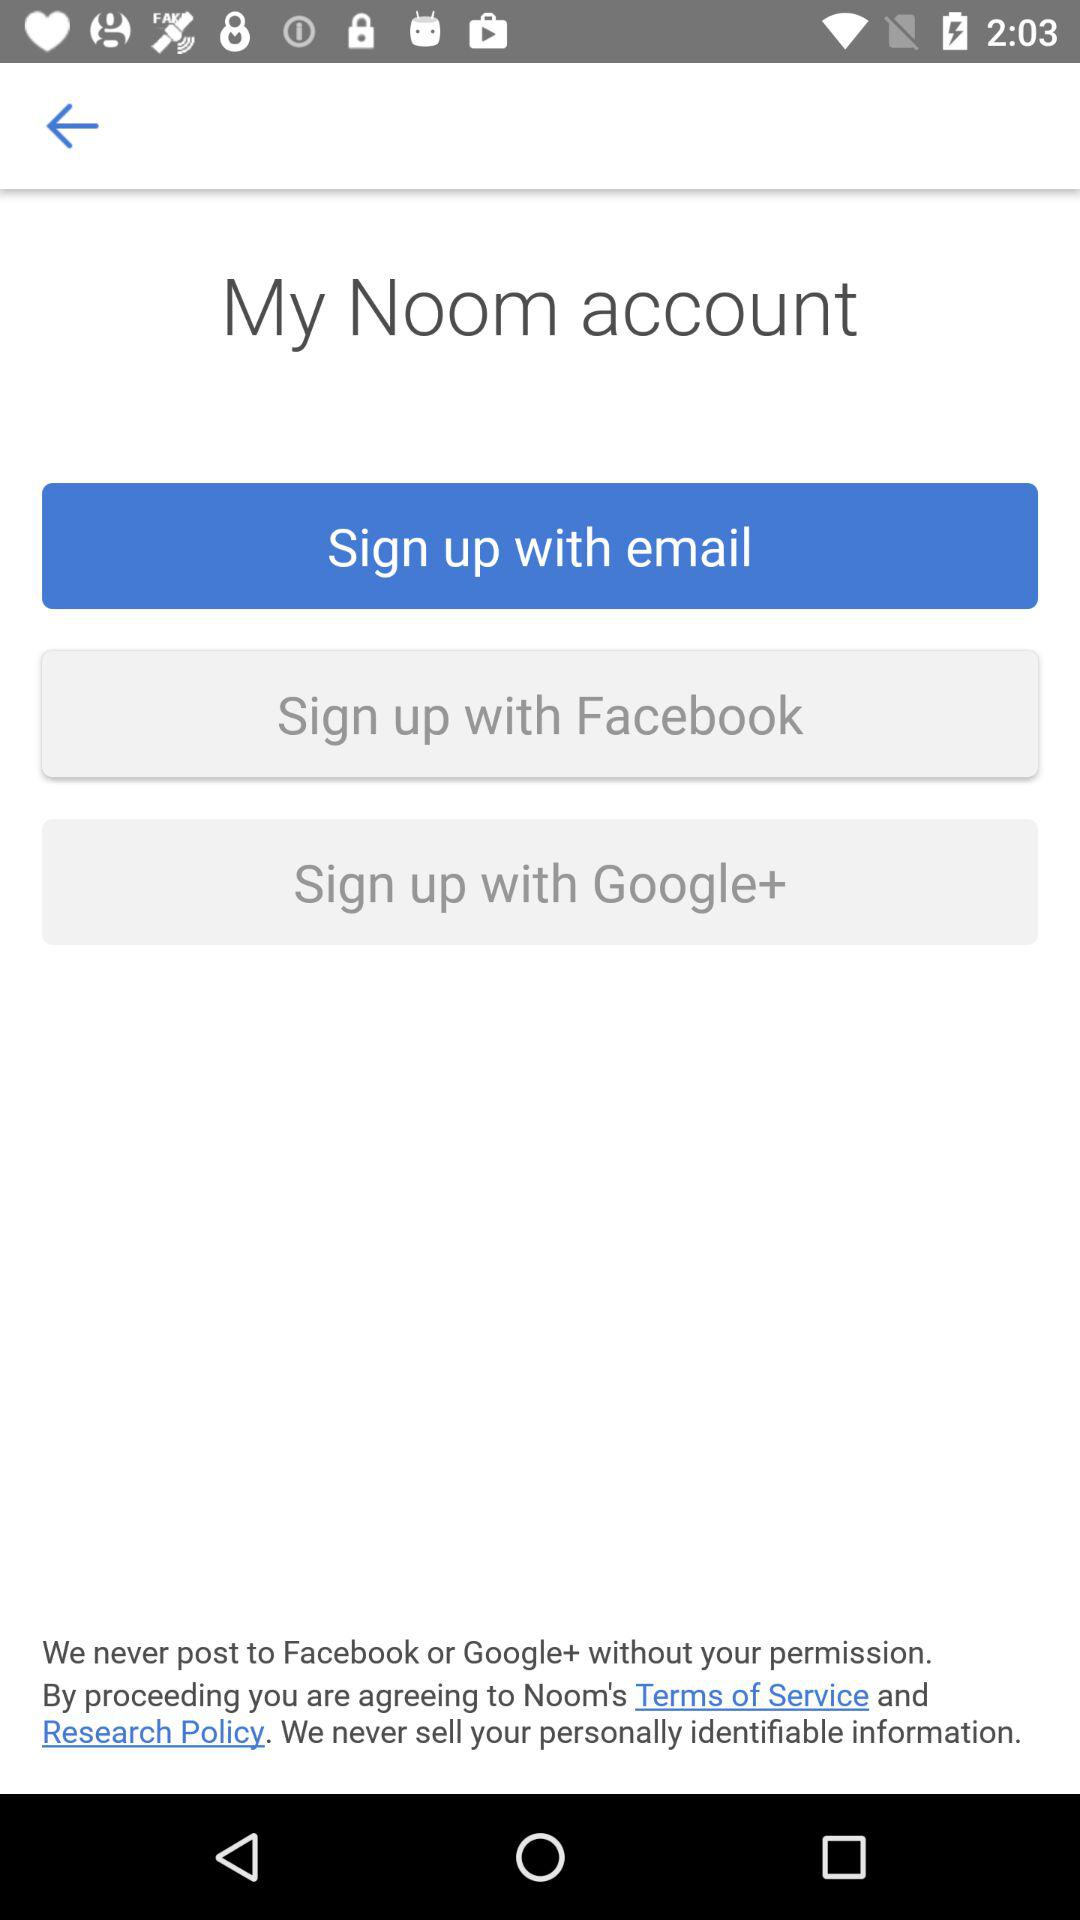How many sign up options are there?
Answer the question using a single word or phrase. 3 